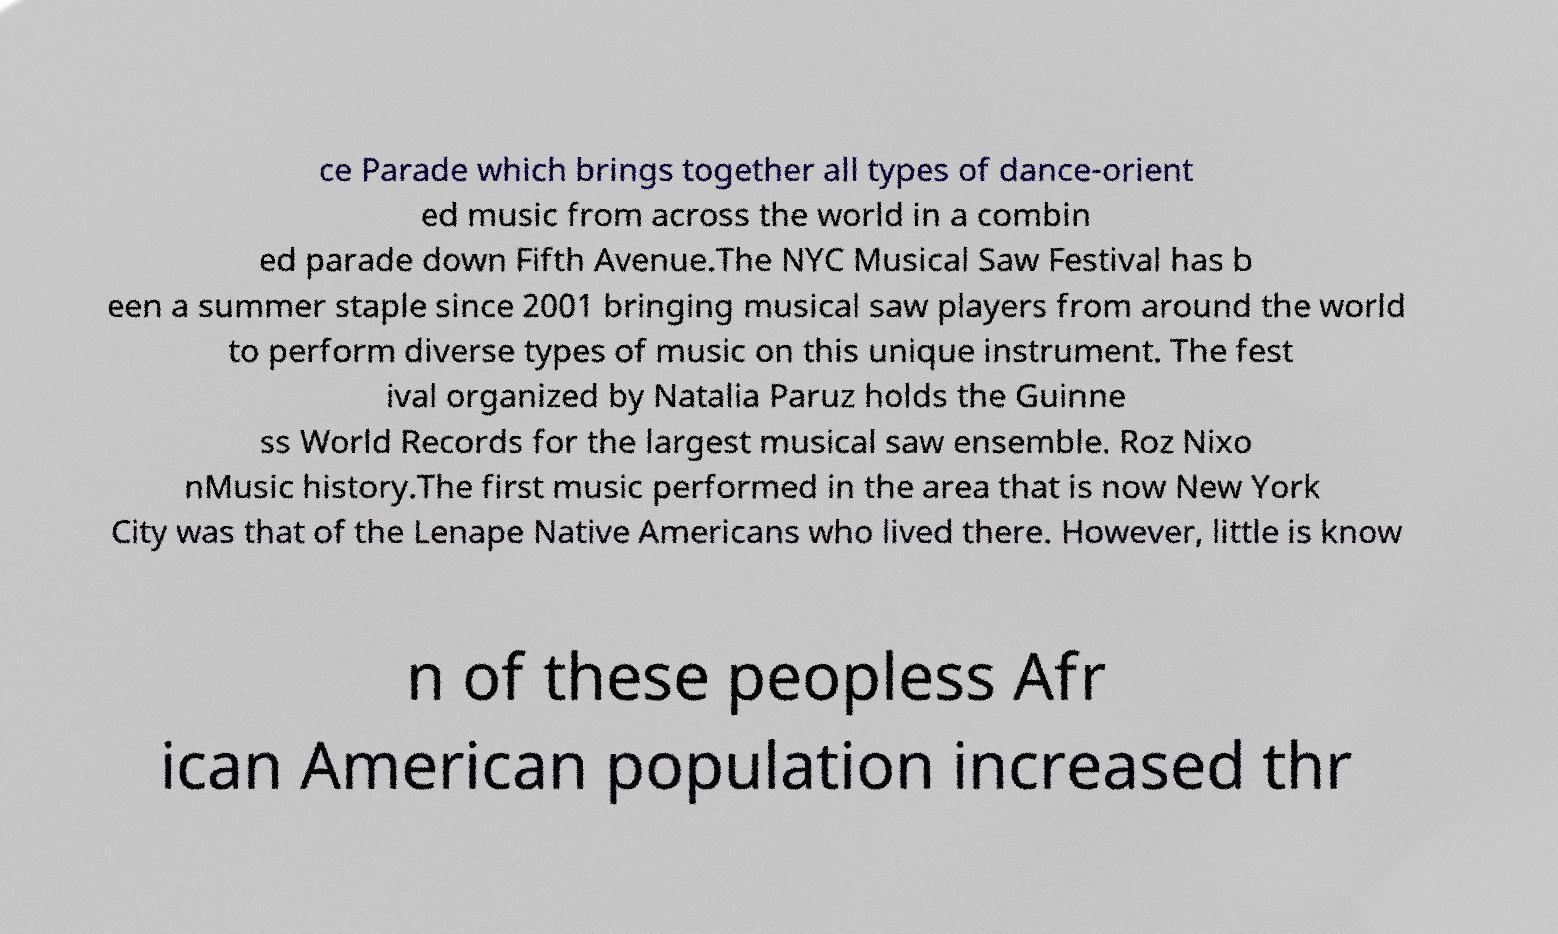Please identify and transcribe the text found in this image. ce Parade which brings together all types of dance-orient ed music from across the world in a combin ed parade down Fifth Avenue.The NYC Musical Saw Festival has b een a summer staple since 2001 bringing musical saw players from around the world to perform diverse types of music on this unique instrument. The fest ival organized by Natalia Paruz holds the Guinne ss World Records for the largest musical saw ensemble. Roz Nixo nMusic history.The first music performed in the area that is now New York City was that of the Lenape Native Americans who lived there. However, little is know n of these peopless Afr ican American population increased thr 